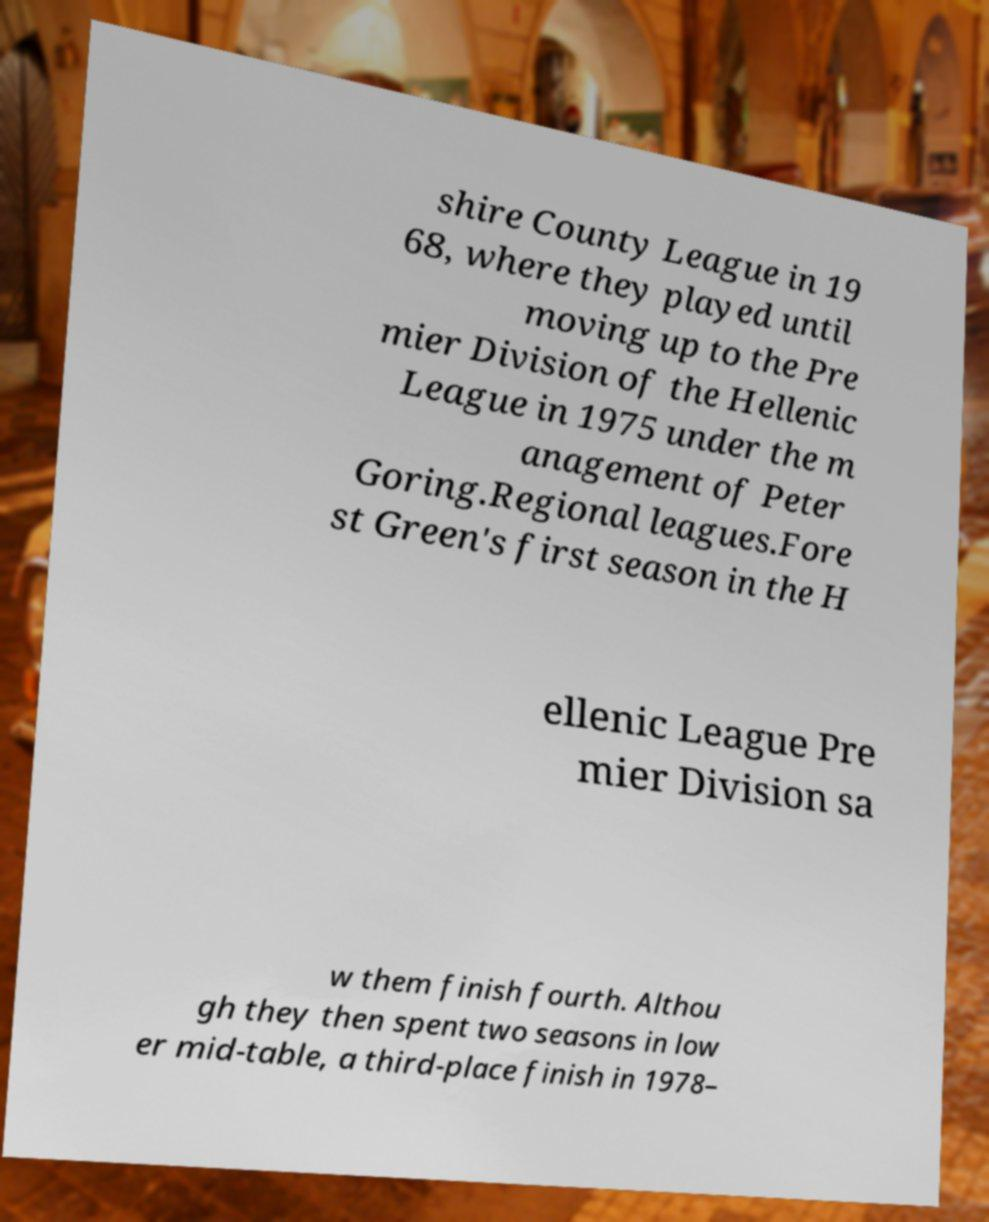I need the written content from this picture converted into text. Can you do that? shire County League in 19 68, where they played until moving up to the Pre mier Division of the Hellenic League in 1975 under the m anagement of Peter Goring.Regional leagues.Fore st Green's first season in the H ellenic League Pre mier Division sa w them finish fourth. Althou gh they then spent two seasons in low er mid-table, a third-place finish in 1978– 